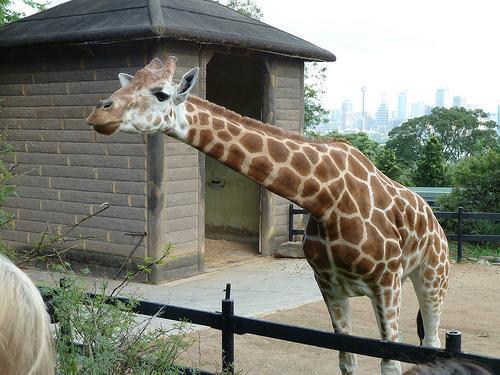How many giraffes are there?
Give a very brief answer. 1. 